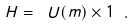Convert formula to latex. <formula><loc_0><loc_0><loc_500><loc_500>H = { \ U ( m ) } \times 1 \ .</formula> 